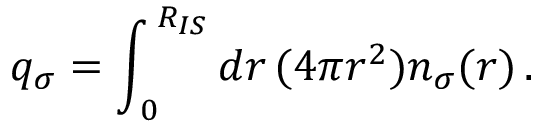<formula> <loc_0><loc_0><loc_500><loc_500>q _ { \sigma } = \int _ { \, 0 } ^ { \, R _ { I S } } d r \, ( 4 \pi r ^ { 2 } ) n _ { \sigma } ( r ) \, .</formula> 